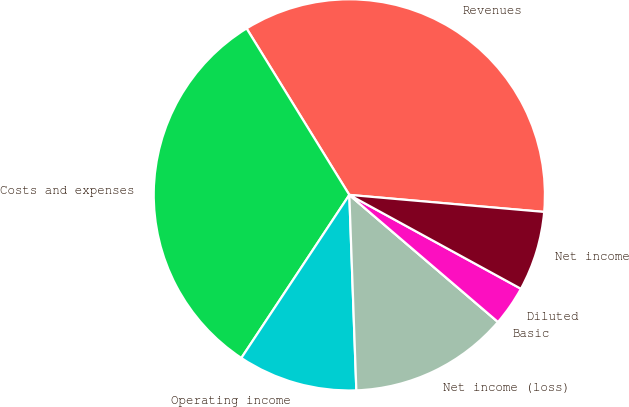Convert chart to OTSL. <chart><loc_0><loc_0><loc_500><loc_500><pie_chart><fcel>Revenues<fcel>Costs and expenses<fcel>Operating income<fcel>Net income (loss)<fcel>Basic<fcel>Diluted<fcel>Net income<nl><fcel>35.19%<fcel>31.89%<fcel>9.88%<fcel>13.17%<fcel>0.0%<fcel>3.29%<fcel>6.58%<nl></chart> 